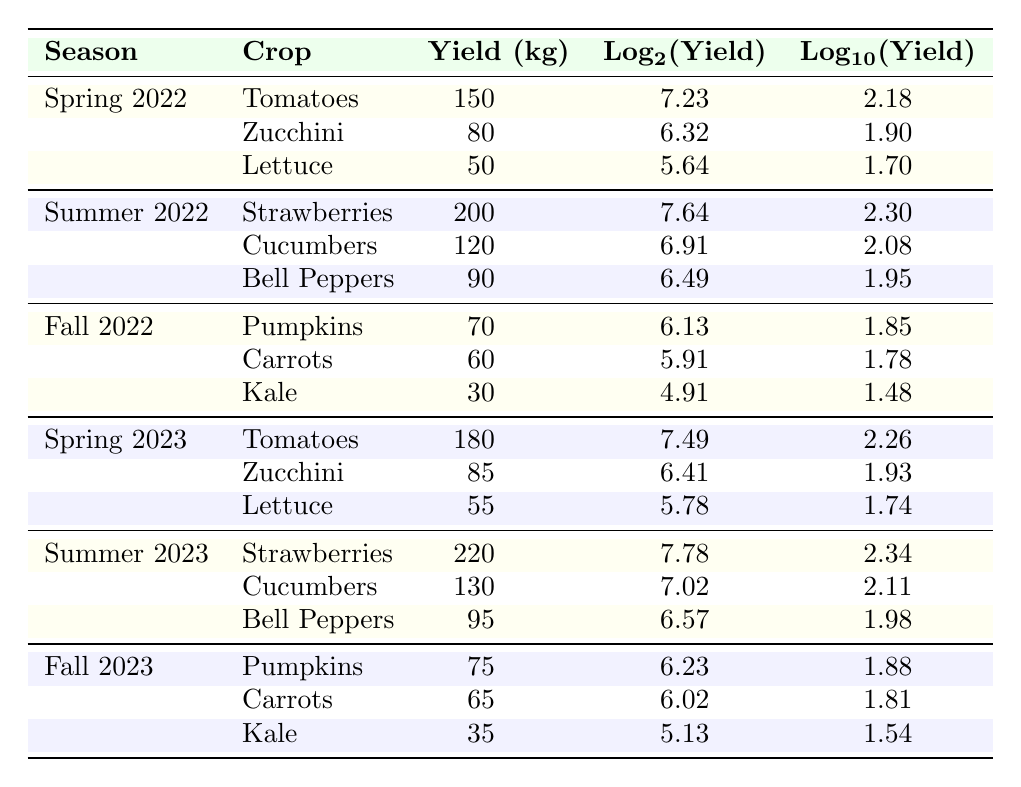What was the yield of tomatoes in Spring 2023? From the table, in the row corresponding to Spring 2023 and the crop of Tomatoes, the yield is listed as 180 kg.
Answer: 180 kg Which crop had the highest yield in Summer 2022? Looking at the Summer 2022 rows, the highest yield is for Strawberries, which is 200 kg.
Answer: Strawberries What is the average yield for cucumbers across all seasons listed? The yields for cucumbers are 120 kg (Summer 2022), 130 kg (Summer 2023). Adding these yields gives 250 kg, and there are 2 data points, so the average yield is 250 kg / 2 = 125 kg.
Answer: 125 kg Did bell peppers yield more in Summer 2023 compared to Summer 2022? In Summer 2022, the yield for bell peppers was 90 kg, while in Summer 2023, it increased to 95 kg. Thus, bell peppers yielded more in Summer 2023.
Answer: Yes What is the total yield of pumpkins from Fall 2022 and Fall 2023? The yield for Pumpkins in Fall 2022 is 70 kg and in Fall 2023 is 75 kg. Adding both yields gives 70 kg + 75 kg = 145 kg.
Answer: 145 kg What was the logarithmic value of lettuce yield in Spring 2022? The yield for Lettuce in Spring 2022 is 50 kg, and the log base 2 value for this yield is approximately 5.64.
Answer: 5.64 Was the yield of carrots higher in Fall 2022 than in Fall 2023? In Fall 2022, the yield for Carrots was 60 kg, while in Fall 2023, it was 65 kg. Hence, the yield was not higher in Fall 2022.
Answer: No Which season had the highest cumulative crop yield? Calculating the total yield for each season: Spring 2022: 150 + 80 + 50 = 280 kg; Summer 2022: 200 + 120 + 90 = 410 kg; Fall 2022: 70 + 60 + 30 = 160 kg; Spring 2023: 180 + 85 + 55 = 320 kg; Summer 2023: 220 + 130 + 95 = 445 kg; Fall 2023: 75 + 65 + 35 = 175 kg. The highest total is from Summer 2023 with 445 kg.
Answer: Summer 2023 What is the difference in yield for zucchinis between Spring 2022 and Spring 2023? For Zucchini in Spring 2022, the yield is 80 kg and in Spring 2023, it is 85 kg. The difference is 85 kg - 80 kg = 5 kg.
Answer: 5 kg 